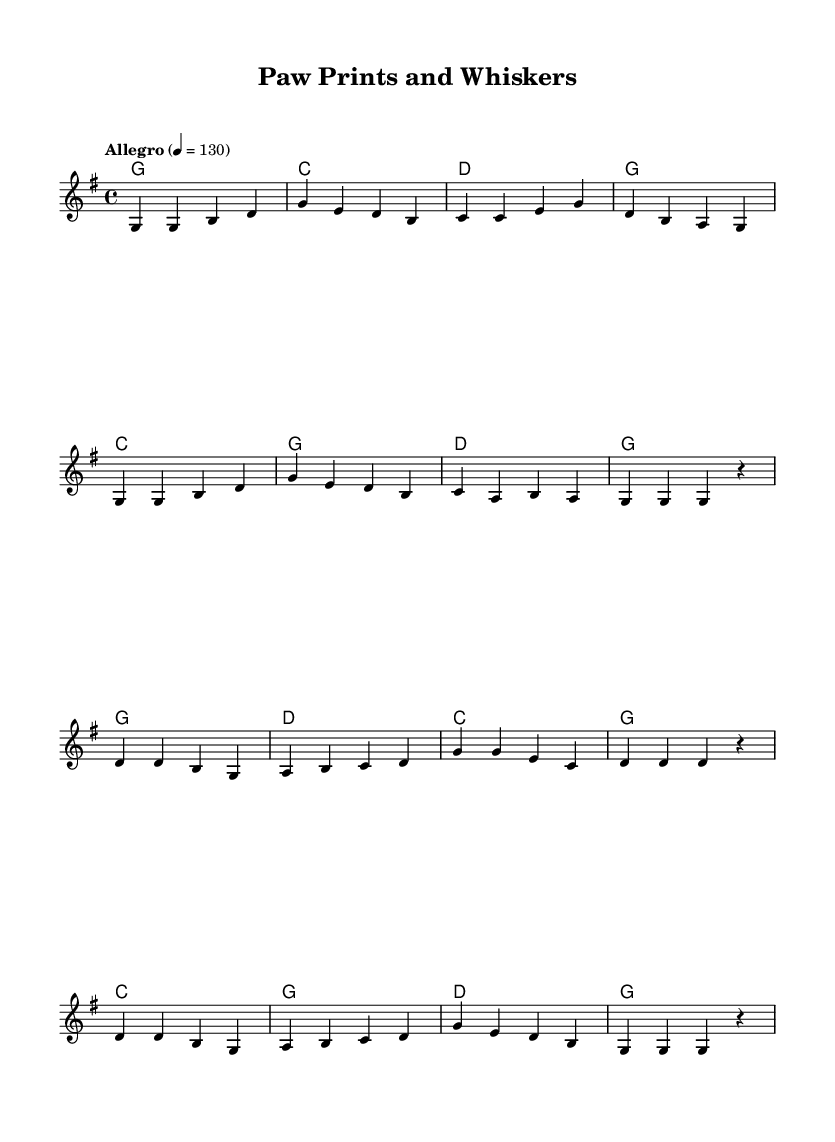What is the key signature of this music? The key signature is G major, which has one sharp (F#). This can be identified by looking at the key signature at the beginning of the sheet music.
Answer: G major What is the time signature of this music? The time signature is 4/4, which indicates there are four beats in each measure. This is shown at the beginning of the sheet music, right after the key signature.
Answer: 4/4 What is the tempo marking of this music? The tempo marking is "Allegro" with a metronome marking of quarter note = 130. This is stated at the beginning of the music under the header.
Answer: Allegro How many measures are in the verse? There are 8 measures in the verse section of the melody. By counting the groups of notes separated by bar lines, you can determine the number of measures.
Answer: 8 What chords are used in the chorus? The chords used in the chorus are G, D, C, and G again, as indicated in the harmonies section of the score. The sequence of chords is clearly laid out to match the melody.
Answer: G, D, C What is the structure of the song? The song follows a structure of verse followed by a chorus. This can be seen in the layout, where the verse melody is presented first, followed by the chorus melody.
Answer: Verse, Chorus Which note is the first note of the melody? The first note of the melody is G. This can be identified by examining the first note indicated in the melody staff.
Answer: G 